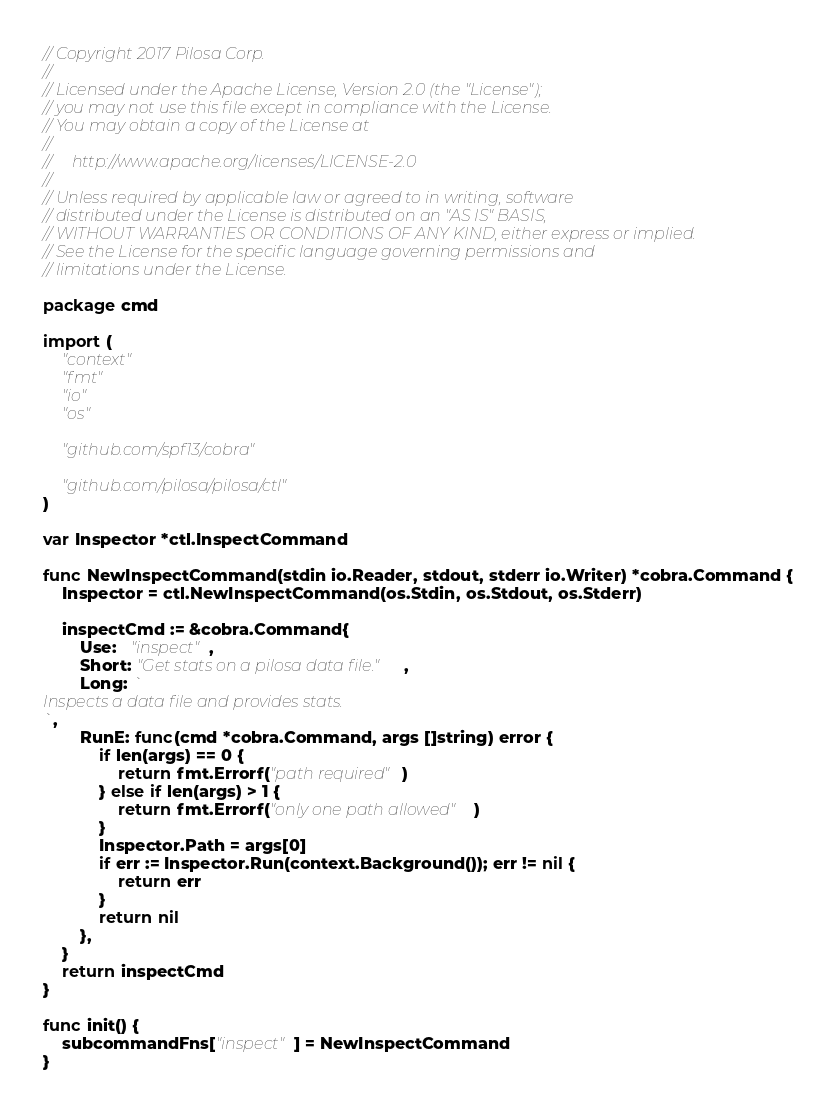<code> <loc_0><loc_0><loc_500><loc_500><_Go_>// Copyright 2017 Pilosa Corp.
//
// Licensed under the Apache License, Version 2.0 (the "License");
// you may not use this file except in compliance with the License.
// You may obtain a copy of the License at
//
//     http://www.apache.org/licenses/LICENSE-2.0
//
// Unless required by applicable law or agreed to in writing, software
// distributed under the License is distributed on an "AS IS" BASIS,
// WITHOUT WARRANTIES OR CONDITIONS OF ANY KIND, either express or implied.
// See the License for the specific language governing permissions and
// limitations under the License.

package cmd

import (
	"context"
	"fmt"
	"io"
	"os"

	"github.com/spf13/cobra"

	"github.com/pilosa/pilosa/ctl"
)

var Inspector *ctl.InspectCommand

func NewInspectCommand(stdin io.Reader, stdout, stderr io.Writer) *cobra.Command {
	Inspector = ctl.NewInspectCommand(os.Stdin, os.Stdout, os.Stderr)

	inspectCmd := &cobra.Command{
		Use:   "inspect",
		Short: "Get stats on a pilosa data file.",
		Long: `
Inspects a data file and provides stats.
`,
		RunE: func(cmd *cobra.Command, args []string) error {
			if len(args) == 0 {
				return fmt.Errorf("path required")
			} else if len(args) > 1 {
				return fmt.Errorf("only one path allowed")
			}
			Inspector.Path = args[0]
			if err := Inspector.Run(context.Background()); err != nil {
				return err
			}
			return nil
		},
	}
	return inspectCmd
}

func init() {
	subcommandFns["inspect"] = NewInspectCommand
}
</code> 